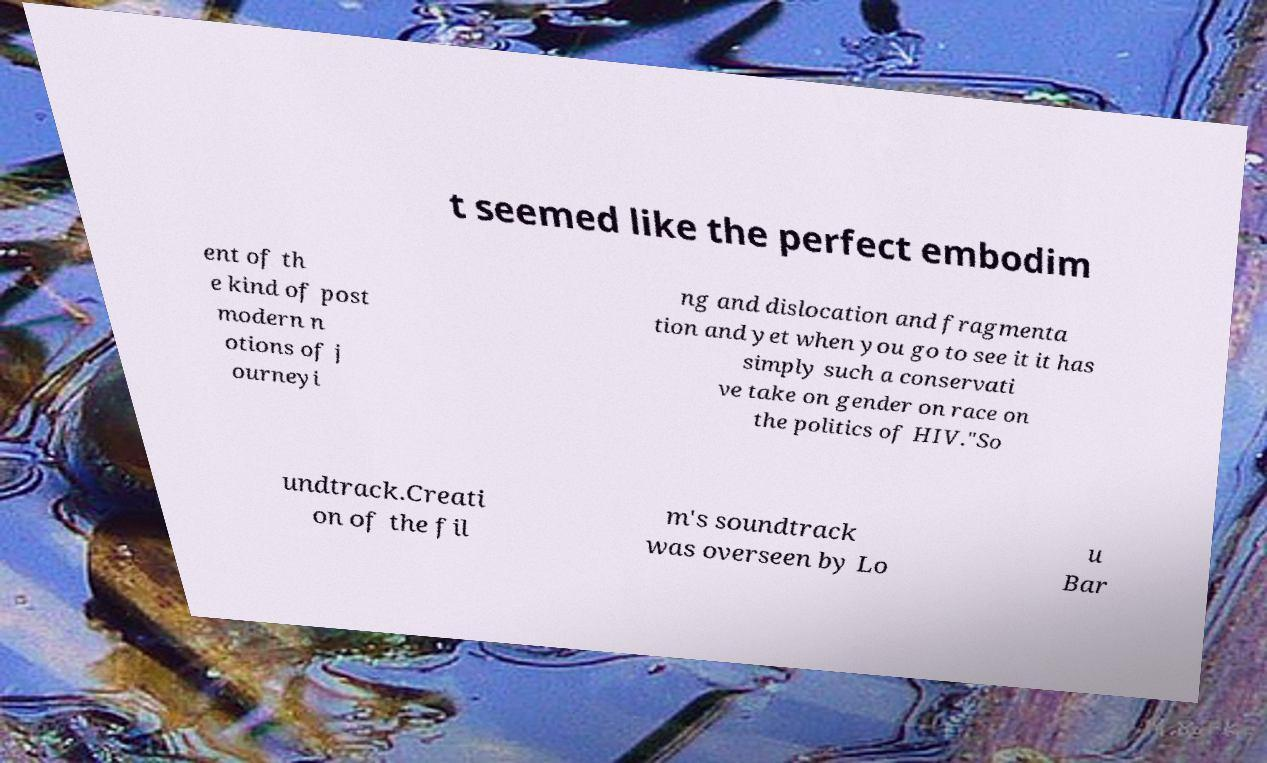There's text embedded in this image that I need extracted. Can you transcribe it verbatim? t seemed like the perfect embodim ent of th e kind of post modern n otions of j ourneyi ng and dislocation and fragmenta tion and yet when you go to see it it has simply such a conservati ve take on gender on race on the politics of HIV."So undtrack.Creati on of the fil m's soundtrack was overseen by Lo u Bar 